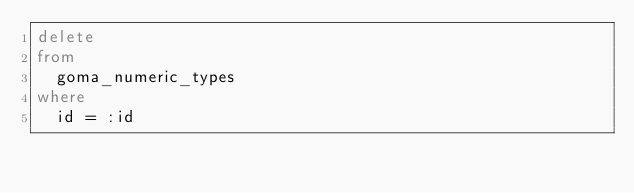<code> <loc_0><loc_0><loc_500><loc_500><_SQL_>delete
from
  goma_numeric_types
where
  id = :id

</code> 